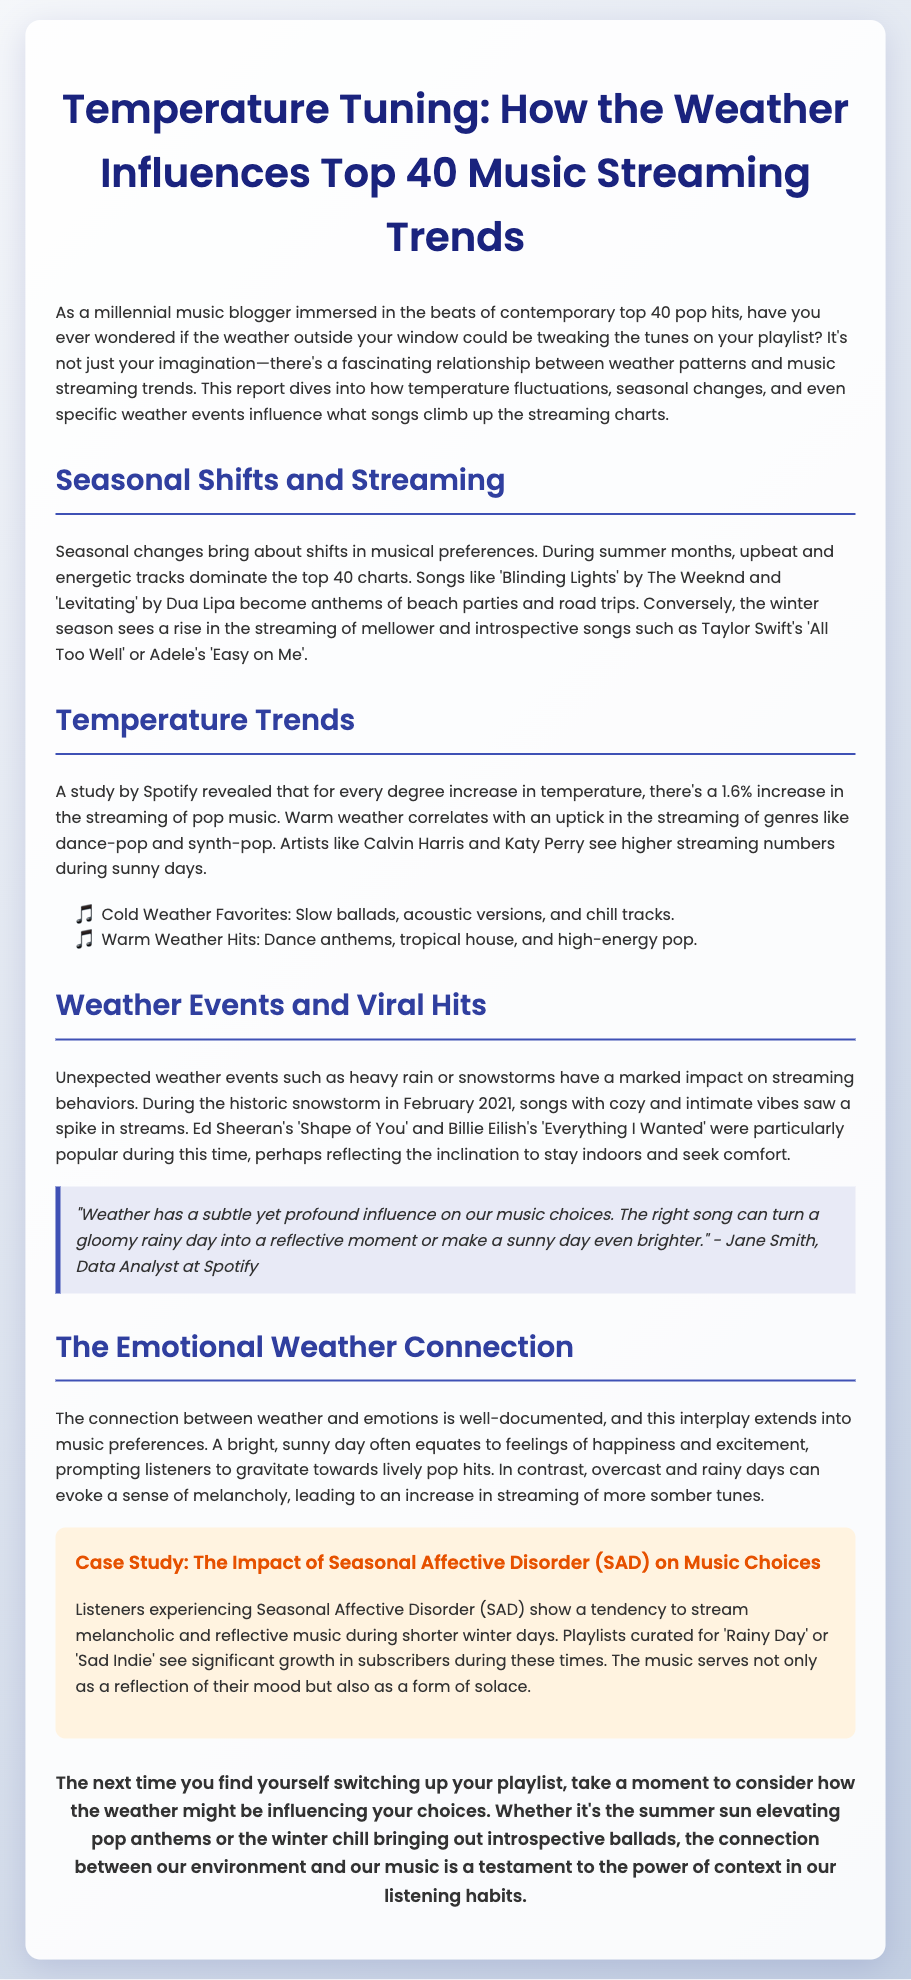What is the title of the report? The title of the report is the heading found at the top of the document, which summarizes its main topic.
Answer: Temperature Tuning: How the Weather Influences Top 40 Music What percentage increase in streaming occurs for every degree rise in temperature? This percentage is specifically mentioned in relation to the effects of temperature on pop music streaming within the document.
Answer: 1.6% Which song by The Weeknd is mentioned as a summer anthem? The document provides examples of songs that are popular during specific seasons and provides details on tracks that accompany warm weather.
Answer: Blinding Lights What type of music sees higher streaming numbers during sunny days? The document categorizes music genres according to the weather and indicates a specific genre that becomes more popular in warm conditions.
Answer: Dance-pop Which emotion is associated with overcast and rainy days? The report discusses how different weather conditions can affect emotional states and consequently influence music preferences.
Answer: Melancholy What phenomenon is associated with melancholic music preferences during winter? This phenomenon is specifically mentioned in the context of how some listeners respond to seasonal changes and their music streaming choices.
Answer: Seasonal Affective Disorder (SAD) Which artists' streaming numbers increase during sunny weather? The document references specific artists to illustrate trends in music streaming related to temperature and weather.
Answer: Calvin Harris and Katy Perry What is the main focus of the case study within the report? The case study highlights a specific phenomenon that connects mental health issues with music choices during certain times of the year.
Answer: Seasonal Affective Disorder (SAD) 